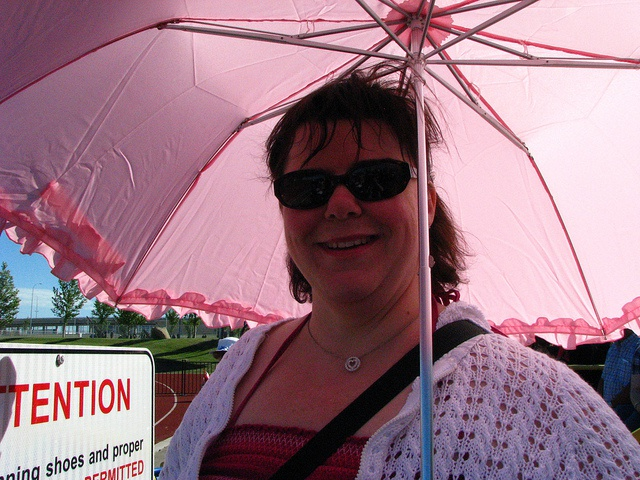Describe the objects in this image and their specific colors. I can see umbrella in purple, pink, lightpink, and brown tones and people in purple, black, maroon, and gray tones in this image. 